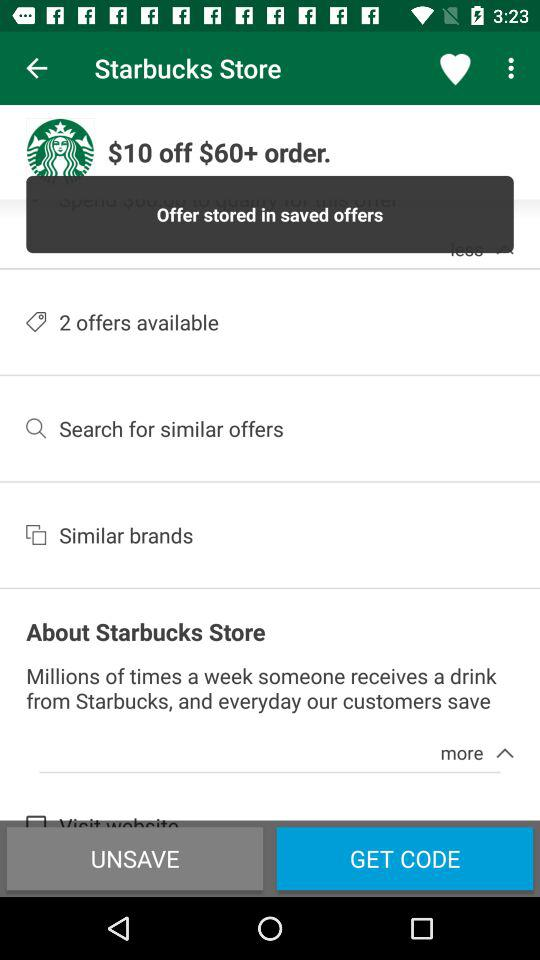What is the selected option?
When the provided information is insufficient, respond with <no answer>. <no answer> 